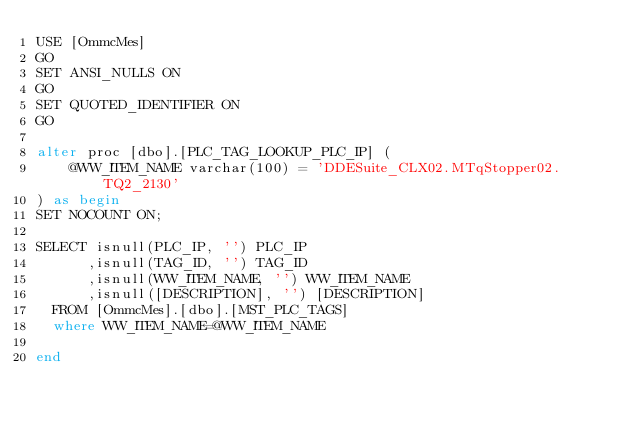Convert code to text. <code><loc_0><loc_0><loc_500><loc_500><_SQL_>USE [OmmcMes]
GO
SET ANSI_NULLS ON
GO
SET QUOTED_IDENTIFIER ON
GO

alter proc [dbo].[PLC_TAG_LOOKUP_PLC_IP] (
	@WW_ITEM_NAME varchar(100) = 'DDESuite_CLX02.MTqStopper02.TQ2_2130'
) as begin
SET NOCOUNT ON;

SELECT isnull(PLC_IP, '') PLC_IP
      ,isnull(TAG_ID, '') TAG_ID
      ,isnull(WW_ITEM_NAME, '') WW_ITEM_NAME
      ,isnull([DESCRIPTION], '') [DESCRIPTION]
  FROM [OmmcMes].[dbo].[MST_PLC_TAGS]
  where WW_ITEM_NAME=@WW_ITEM_NAME

end
</code> 